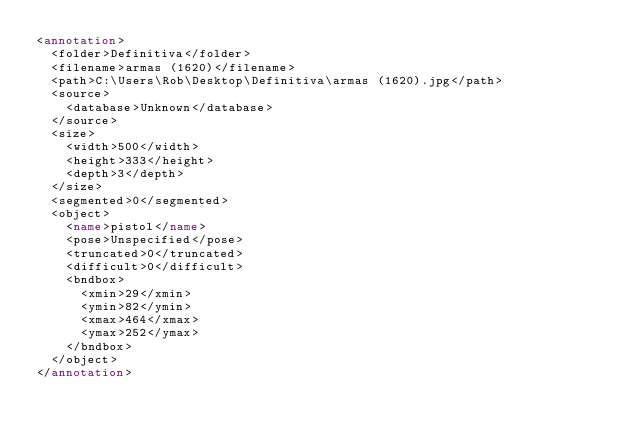Convert code to text. <code><loc_0><loc_0><loc_500><loc_500><_XML_><annotation>
  <folder>Definitiva</folder>
  <filename>armas (1620)</filename>
  <path>C:\Users\Rob\Desktop\Definitiva\armas (1620).jpg</path>
  <source>
    <database>Unknown</database>
  </source>
  <size>
    <width>500</width>
    <height>333</height>
    <depth>3</depth>
  </size>
  <segmented>0</segmented>
  <object>
    <name>pistol</name>
    <pose>Unspecified</pose>
    <truncated>0</truncated>
    <difficult>0</difficult>
    <bndbox>
      <xmin>29</xmin>
      <ymin>82</ymin>
      <xmax>464</xmax>
      <ymax>252</ymax>
    </bndbox>
  </object>
</annotation>
</code> 